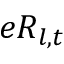<formula> <loc_0><loc_0><loc_500><loc_500>e R _ { l , t }</formula> 